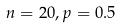Convert formula to latex. <formula><loc_0><loc_0><loc_500><loc_500>n = 2 0 , p = 0 . 5</formula> 